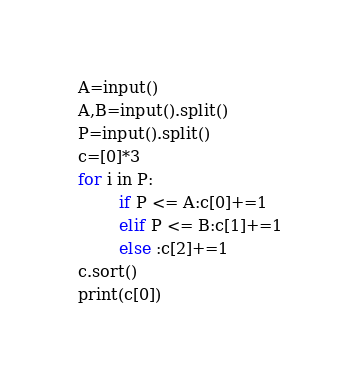<code> <loc_0><loc_0><loc_500><loc_500><_Python_>A=input()
A,B=input().split()
P=input().split()
c=[0]*3
for i in P:
        if P <= A:c[0]+=1
        elif P <= B:c[1]+=1
        else :c[2]+=1
c.sort()
print(c[0])</code> 